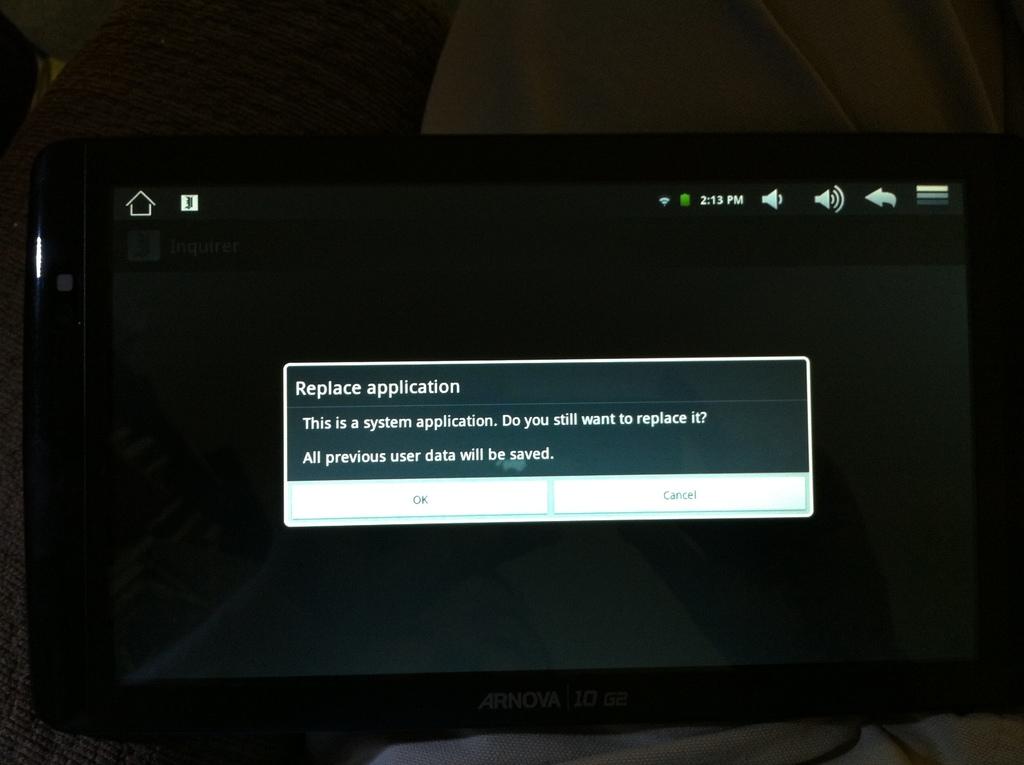What is the error on the screen?
Ensure brevity in your answer.  Replace application. Will all previous user data be saved?
Ensure brevity in your answer.  Yes. 